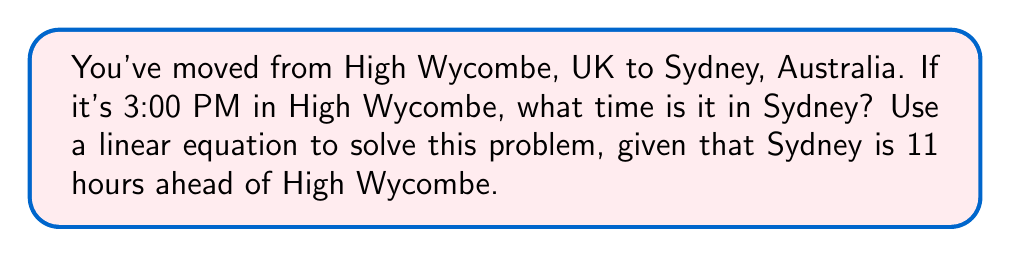Provide a solution to this math problem. Let's approach this step-by-step using a linear equation:

1) Let $x$ be the time in Sydney in hours.
2) Let $y$ be the time in High Wycombe in hours.

We know that Sydney is 11 hours ahead of High Wycombe, so we can write:

$$ x = y + 11 $$

We're given that it's 3:00 PM (15:00) in High Wycombe, so $y = 15$.

Substituting this into our equation:

$$ x = 15 + 11 $$
$$ x = 26 $$

However, we need to convert this to a 24-hour clock format. We can do this by subtracting 24 if the result is greater than 24:

$$ x \equiv 26 \pmod{24} $$
$$ x = 26 - 24 = 2 $$

Therefore, when it's 3:00 PM (15:00) in High Wycombe, it's 2:00 AM the next day in Sydney.
Answer: 2:00 AM (next day) 